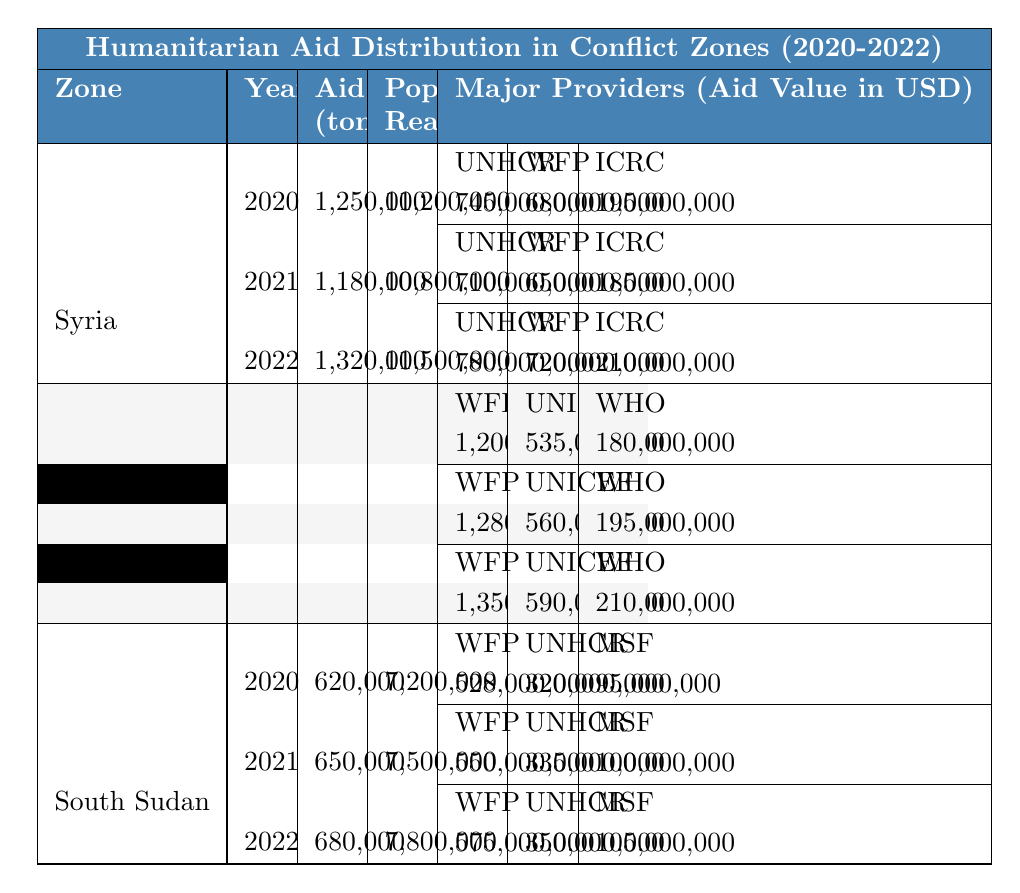What was the total aid distributed in Syria in 2020? From the table, the aid distributed in Syria for 2020 is directly stated to be 1,250,000 tons.
Answer: 1,250,000 tons Which organization provided the highest aid value in Yemen in 2021? According to the table for Yemen in 2021, the organization with the highest aid value is the World Food Programme with an aid value of 1,280,000,000 USD.
Answer: World Food Programme What is the aggregate aid distributed across all three zones in 2022? To find the total aid for 2022, add the figures from each zone: Syria (1,320,000) + Yemen (1,120,000) + South Sudan (680,000) = 3,120,000 tons.
Answer: 3,120,000 tons Did the population reached in Yemen grow larger from 2020 to 2022? In the table, the population reached in Yemen is 18,500,000 in 2020 and increases to 20,100,000 in 2022, which confirms it grew larger.
Answer: Yes What is the average aid distributed per person reached in Syria for 2021? For Syria in 2021, aid distributed is 1,180,000 tons and the population reached is 10,800,000. So, average aid per person is (1,180,000 tons) / (10,800,000 people) = approximately 0.109 tons per person.
Answer: Approximately 0.109 tons What was the change in aid distributed in South Sudan from 2020 to 2022? The aid distributed in South Sudan was 620,000 tons in 2020 and increased to 680,000 tons in 2022. The change is calculated as 680,000 - 620,000 = 60,000 tons, indicating an increase.
Answer: Increased by 60,000 tons How much aid did the ICRC provide in total across all years in Syria? In the table for Syria, the ICRC aid values are: 195,000,000 in 2020, 185,000,000 in 2021, and 210,000,000 in 2022. Summing these gives: 195,000,000 + 185,000,000 + 210,000,000 = 590,000,000 USD total aid from ICRC.
Answer: 590,000,000 USD Which zone had the highest population reached in 2020, and what was that figure? Reviewing the table, Yemen had the highest population reached in 2020 at 18,500,000, compared to Syria and South Sudan which had less.
Answer: Yemen, 18,500,000 Is it true that the aid distributed in Yemen decreased from 2021 to 2022? In examining the figures from the table, Yemen's aid distributed increased from 1,050,000 tons in 2021 to 1,120,000 tons in 2022, indicating an increase, not a decrease.
Answer: No What was the average aid value provided by the UNHCR in Syria over the three years? From the table, the UNHCR aid values in Syria are: 745,000,000 in 2020, 710,000,000 in 2021, and 780,000,000 in 2022. Summing these gives 2,235,000,000. The average is 2,235,000,000 / 3 = 745,000,000 USD.
Answer: 745,000,000 USD 